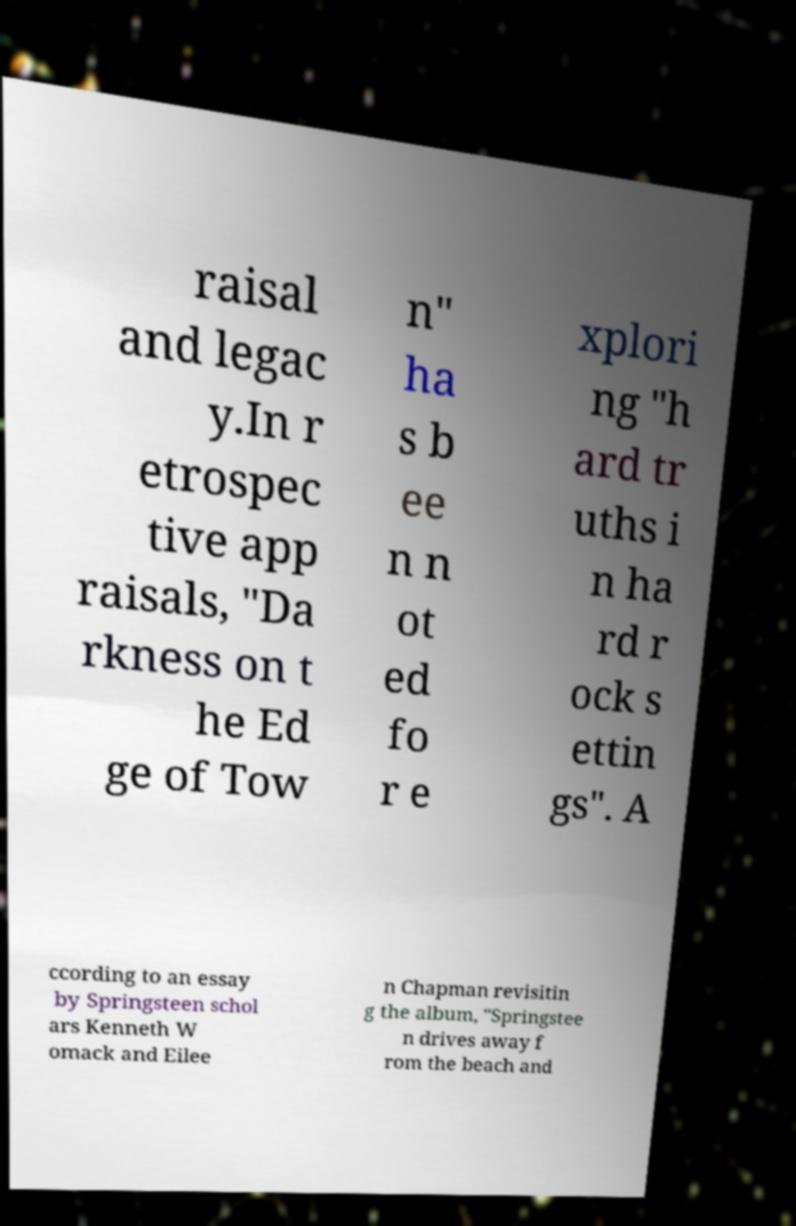Could you extract and type out the text from this image? raisal and legac y.In r etrospec tive app raisals, "Da rkness on t he Ed ge of Tow n" ha s b ee n n ot ed fo r e xplori ng "h ard tr uths i n ha rd r ock s ettin gs". A ccording to an essay by Springsteen schol ars Kenneth W omack and Eilee n Chapman revisitin g the album, "Springstee n drives away f rom the beach and 